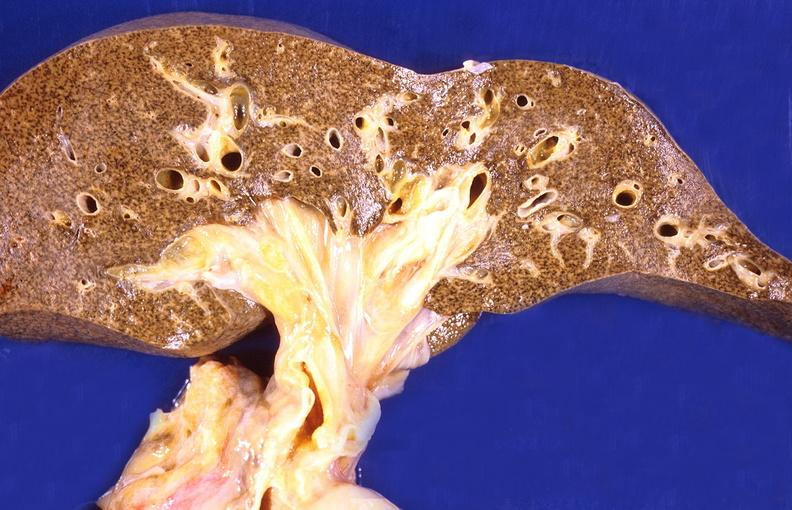does cranial artery show cirrhosis?
Answer the question using a single word or phrase. No 